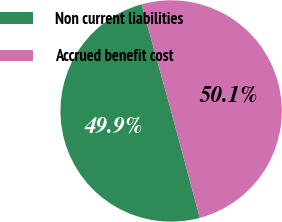<chart> <loc_0><loc_0><loc_500><loc_500><pie_chart><fcel>Non current liabilities<fcel>Accrued benefit cost<nl><fcel>49.88%<fcel>50.12%<nl></chart> 